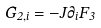<formula> <loc_0><loc_0><loc_500><loc_500>G _ { 2 , i } = - J \partial _ { i } F _ { 3 }</formula> 